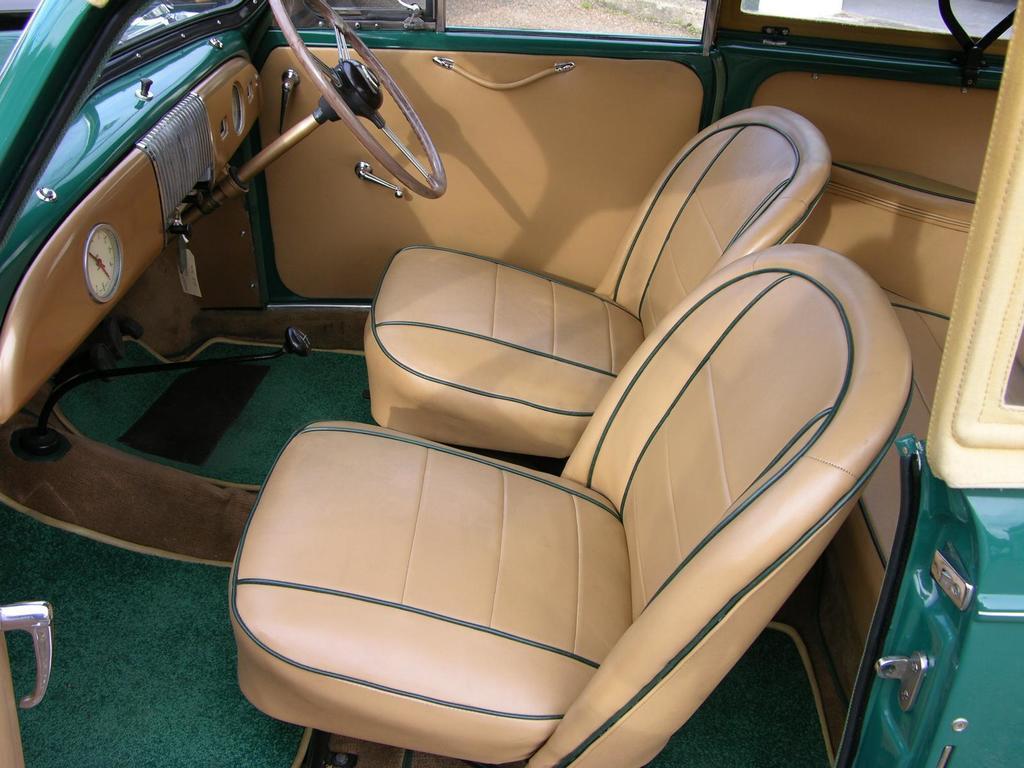Describe this image in one or two sentences. In this picture we can see the inside view of a vehicle. In the vehicle there are seats, steering and a gear lever. 